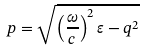<formula> <loc_0><loc_0><loc_500><loc_500>p = \sqrt { \left ( \frac { \omega } { c } \right ) ^ { 2 } \varepsilon - q ^ { 2 } }</formula> 